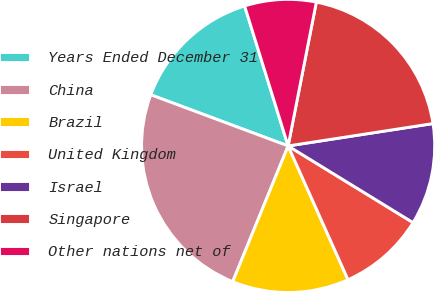Convert chart. <chart><loc_0><loc_0><loc_500><loc_500><pie_chart><fcel>Years Ended December 31<fcel>China<fcel>Brazil<fcel>United Kingdom<fcel>Israel<fcel>Singapore<fcel>Other nations net of<nl><fcel>14.53%<fcel>24.51%<fcel>12.87%<fcel>9.54%<fcel>11.2%<fcel>19.48%<fcel>7.88%<nl></chart> 